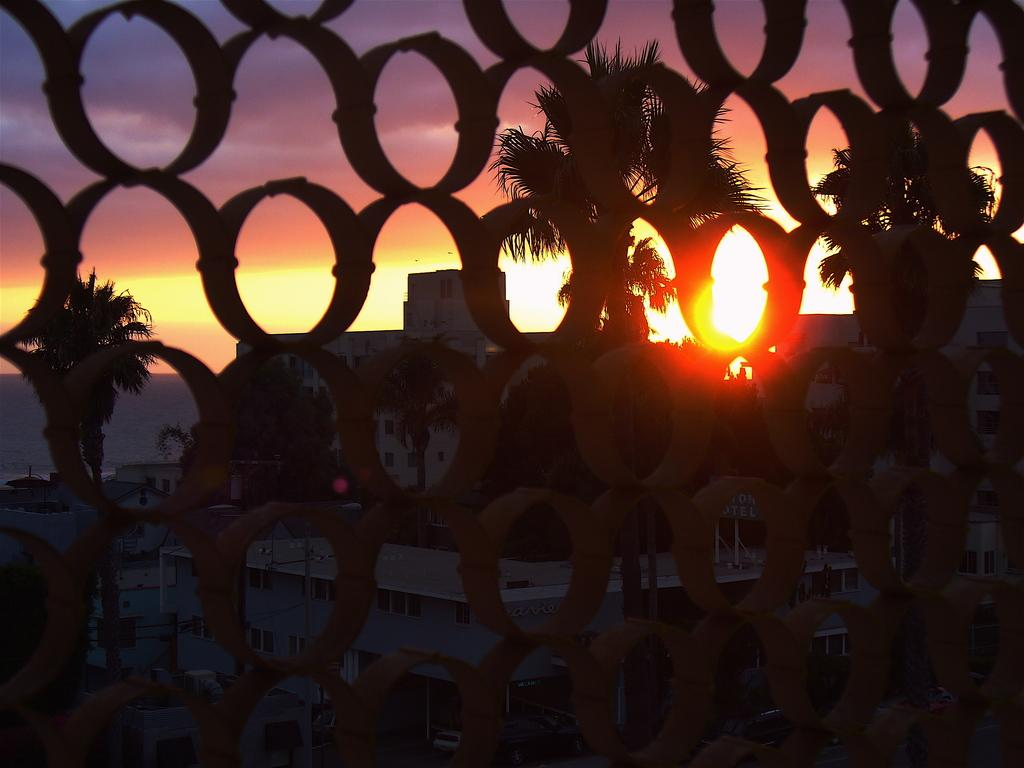What type of natural elements can be seen in the image? There are trees visible in the image. What type of man-made structures can be seen in the image? There are buildings visible in the image. What part of the natural environment is visible in the image? The sky is visible in the image. What object is present in the image that might be used for displaying information? There is a board visible in the image. What type of lighting is present in the image? Sunlight is present in the image. What type of skirt is the judge wearing in the image? There is no judge or skirt present in the image. What is the opinion of the person in the image regarding the topic of climate change? There is no indication of anyone's opinion regarding climate change in the image. 